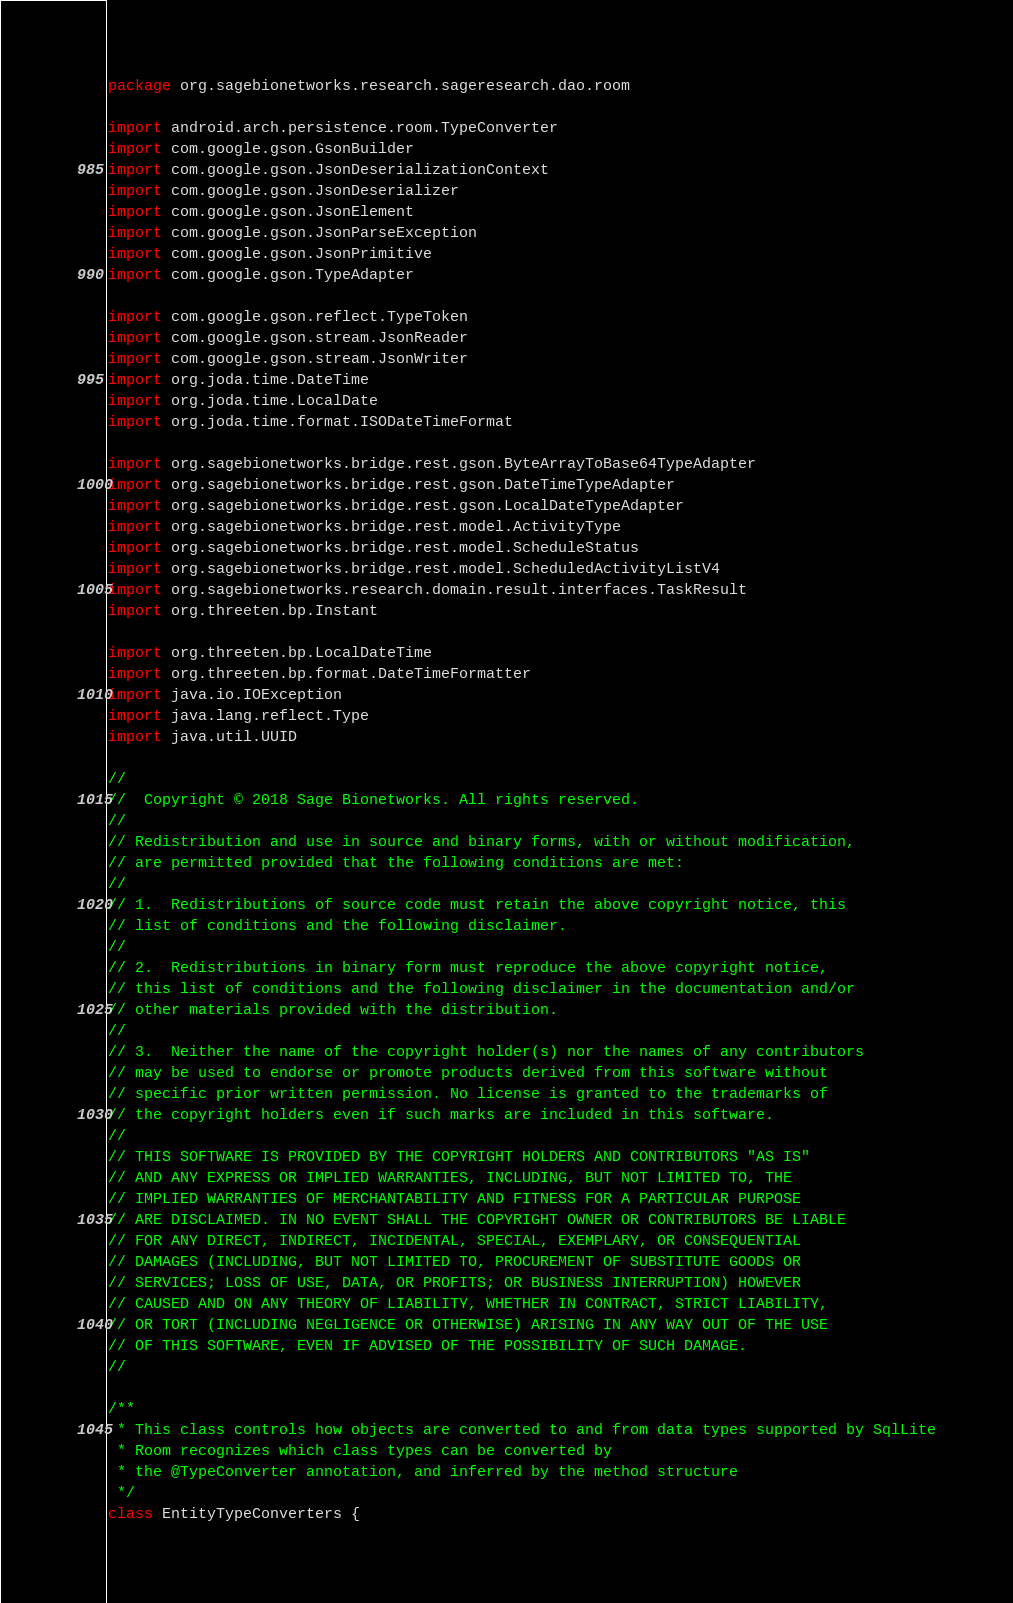<code> <loc_0><loc_0><loc_500><loc_500><_Kotlin_>package org.sagebionetworks.research.sageresearch.dao.room

import android.arch.persistence.room.TypeConverter
import com.google.gson.GsonBuilder
import com.google.gson.JsonDeserializationContext
import com.google.gson.JsonDeserializer
import com.google.gson.JsonElement
import com.google.gson.JsonParseException
import com.google.gson.JsonPrimitive
import com.google.gson.TypeAdapter

import com.google.gson.reflect.TypeToken
import com.google.gson.stream.JsonReader
import com.google.gson.stream.JsonWriter
import org.joda.time.DateTime
import org.joda.time.LocalDate
import org.joda.time.format.ISODateTimeFormat

import org.sagebionetworks.bridge.rest.gson.ByteArrayToBase64TypeAdapter
import org.sagebionetworks.bridge.rest.gson.DateTimeTypeAdapter
import org.sagebionetworks.bridge.rest.gson.LocalDateTypeAdapter
import org.sagebionetworks.bridge.rest.model.ActivityType
import org.sagebionetworks.bridge.rest.model.ScheduleStatus
import org.sagebionetworks.bridge.rest.model.ScheduledActivityListV4
import org.sagebionetworks.research.domain.result.interfaces.TaskResult
import org.threeten.bp.Instant

import org.threeten.bp.LocalDateTime
import org.threeten.bp.format.DateTimeFormatter
import java.io.IOException
import java.lang.reflect.Type
import java.util.UUID

//
//  Copyright © 2018 Sage Bionetworks. All rights reserved.
//
// Redistribution and use in source and binary forms, with or without modification,
// are permitted provided that the following conditions are met:
//
// 1.  Redistributions of source code must retain the above copyright notice, this
// list of conditions and the following disclaimer.
//
// 2.  Redistributions in binary form must reproduce the above copyright notice,
// this list of conditions and the following disclaimer in the documentation and/or
// other materials provided with the distribution.
//
// 3.  Neither the name of the copyright holder(s) nor the names of any contributors
// may be used to endorse or promote products derived from this software without
// specific prior written permission. No license is granted to the trademarks of
// the copyright holders even if such marks are included in this software.
//
// THIS SOFTWARE IS PROVIDED BY THE COPYRIGHT HOLDERS AND CONTRIBUTORS "AS IS"
// AND ANY EXPRESS OR IMPLIED WARRANTIES, INCLUDING, BUT NOT LIMITED TO, THE
// IMPLIED WARRANTIES OF MERCHANTABILITY AND FITNESS FOR A PARTICULAR PURPOSE
// ARE DISCLAIMED. IN NO EVENT SHALL THE COPYRIGHT OWNER OR CONTRIBUTORS BE LIABLE
// FOR ANY DIRECT, INDIRECT, INCIDENTAL, SPECIAL, EXEMPLARY, OR CONSEQUENTIAL
// DAMAGES (INCLUDING, BUT NOT LIMITED TO, PROCUREMENT OF SUBSTITUTE GOODS OR
// SERVICES; LOSS OF USE, DATA, OR PROFITS; OR BUSINESS INTERRUPTION) HOWEVER
// CAUSED AND ON ANY THEORY OF LIABILITY, WHETHER IN CONTRACT, STRICT LIABILITY,
// OR TORT (INCLUDING NEGLIGENCE OR OTHERWISE) ARISING IN ANY WAY OUT OF THE USE
// OF THIS SOFTWARE, EVEN IF ADVISED OF THE POSSIBILITY OF SUCH DAMAGE.
//

/**
 * This class controls how objects are converted to and from data types supported by SqlLite
 * Room recognizes which class types can be converted by
 * the @TypeConverter annotation, and inferred by the method structure
 */
class EntityTypeConverters {
</code> 